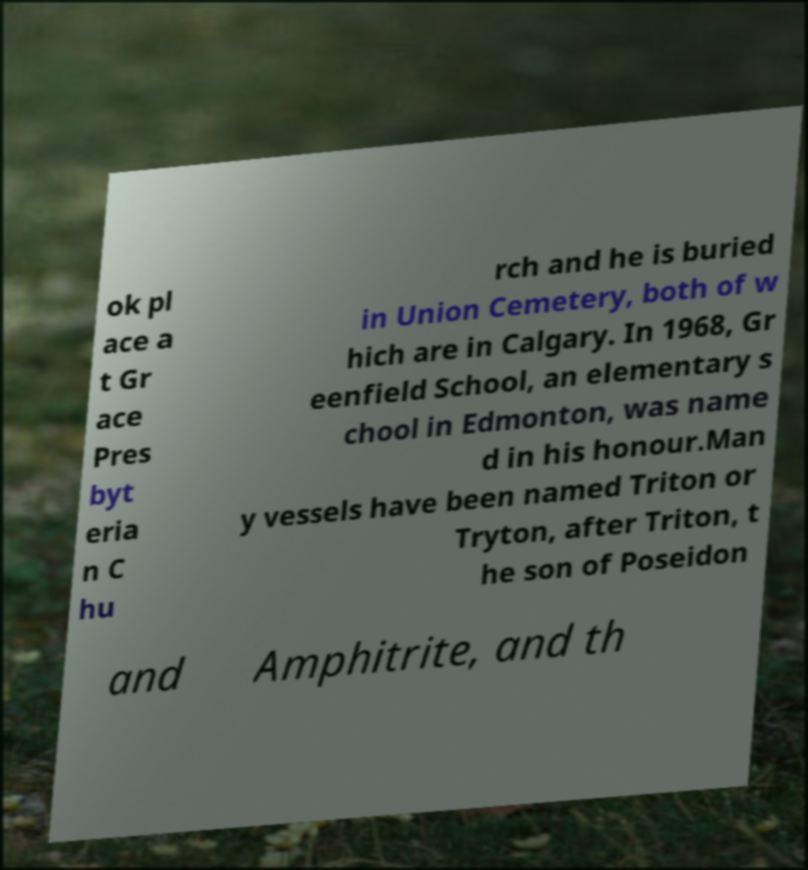Could you assist in decoding the text presented in this image and type it out clearly? ok pl ace a t Gr ace Pres byt eria n C hu rch and he is buried in Union Cemetery, both of w hich are in Calgary. In 1968, Gr eenfield School, an elementary s chool in Edmonton, was name d in his honour.Man y vessels have been named Triton or Tryton, after Triton, t he son of Poseidon and Amphitrite, and th 